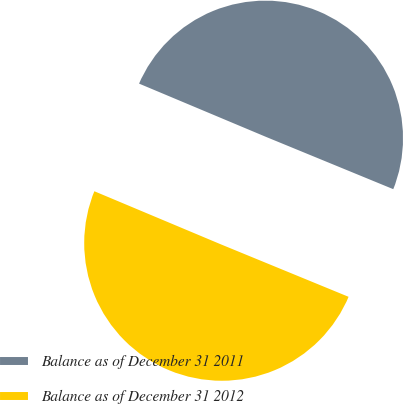<chart> <loc_0><loc_0><loc_500><loc_500><pie_chart><fcel>Balance as of December 31 2011<fcel>Balance as of December 31 2012<nl><fcel>49.88%<fcel>50.12%<nl></chart> 